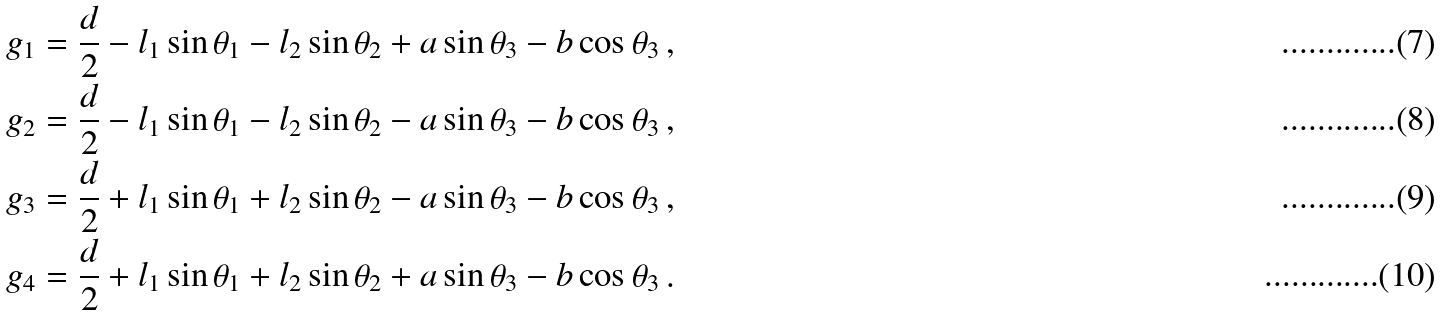Convert formula to latex. <formula><loc_0><loc_0><loc_500><loc_500>g _ { 1 } & = \frac { d } { 2 } - l _ { 1 } \sin \theta _ { 1 } - l _ { 2 } \sin \theta _ { 2 } + a \sin \theta _ { 3 } - b \cos \theta _ { 3 } \, , \\ g _ { 2 } & = \frac { d } { 2 } - l _ { 1 } \sin \theta _ { 1 } - l _ { 2 } \sin \theta _ { 2 } - a \sin \theta _ { 3 } - b \cos \theta _ { 3 } \, , \\ g _ { 3 } & = \frac { d } { 2 } + l _ { 1 } \sin \theta _ { 1 } + l _ { 2 } \sin \theta _ { 2 } - a \sin \theta _ { 3 } - b \cos \theta _ { 3 } \, , \\ g _ { 4 } & = \frac { d } { 2 } + l _ { 1 } \sin \theta _ { 1 } + l _ { 2 } \sin \theta _ { 2 } + a \sin \theta _ { 3 } - b \cos \theta _ { 3 } \, .</formula> 